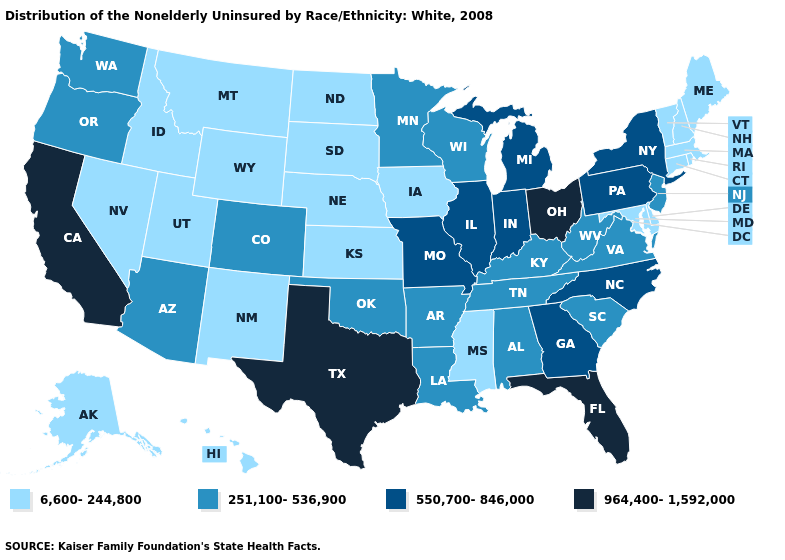What is the lowest value in the USA?
Be succinct. 6,600-244,800. Name the states that have a value in the range 251,100-536,900?
Concise answer only. Alabama, Arizona, Arkansas, Colorado, Kentucky, Louisiana, Minnesota, New Jersey, Oklahoma, Oregon, South Carolina, Tennessee, Virginia, Washington, West Virginia, Wisconsin. What is the value of Minnesota?
Write a very short answer. 251,100-536,900. What is the value of Nebraska?
Keep it brief. 6,600-244,800. Name the states that have a value in the range 251,100-536,900?
Keep it brief. Alabama, Arizona, Arkansas, Colorado, Kentucky, Louisiana, Minnesota, New Jersey, Oklahoma, Oregon, South Carolina, Tennessee, Virginia, Washington, West Virginia, Wisconsin. Does New York have the highest value in the Northeast?
Be succinct. Yes. Name the states that have a value in the range 6,600-244,800?
Short answer required. Alaska, Connecticut, Delaware, Hawaii, Idaho, Iowa, Kansas, Maine, Maryland, Massachusetts, Mississippi, Montana, Nebraska, Nevada, New Hampshire, New Mexico, North Dakota, Rhode Island, South Dakota, Utah, Vermont, Wyoming. Does Mississippi have the highest value in the South?
Answer briefly. No. Does Idaho have the lowest value in the West?
Concise answer only. Yes. Name the states that have a value in the range 550,700-846,000?
Short answer required. Georgia, Illinois, Indiana, Michigan, Missouri, New York, North Carolina, Pennsylvania. Which states have the lowest value in the USA?
Short answer required. Alaska, Connecticut, Delaware, Hawaii, Idaho, Iowa, Kansas, Maine, Maryland, Massachusetts, Mississippi, Montana, Nebraska, Nevada, New Hampshire, New Mexico, North Dakota, Rhode Island, South Dakota, Utah, Vermont, Wyoming. Name the states that have a value in the range 6,600-244,800?
Keep it brief. Alaska, Connecticut, Delaware, Hawaii, Idaho, Iowa, Kansas, Maine, Maryland, Massachusetts, Mississippi, Montana, Nebraska, Nevada, New Hampshire, New Mexico, North Dakota, Rhode Island, South Dakota, Utah, Vermont, Wyoming. Does Oklahoma have a higher value than Vermont?
Concise answer only. Yes. What is the value of New Jersey?
Concise answer only. 251,100-536,900. Name the states that have a value in the range 550,700-846,000?
Write a very short answer. Georgia, Illinois, Indiana, Michigan, Missouri, New York, North Carolina, Pennsylvania. 